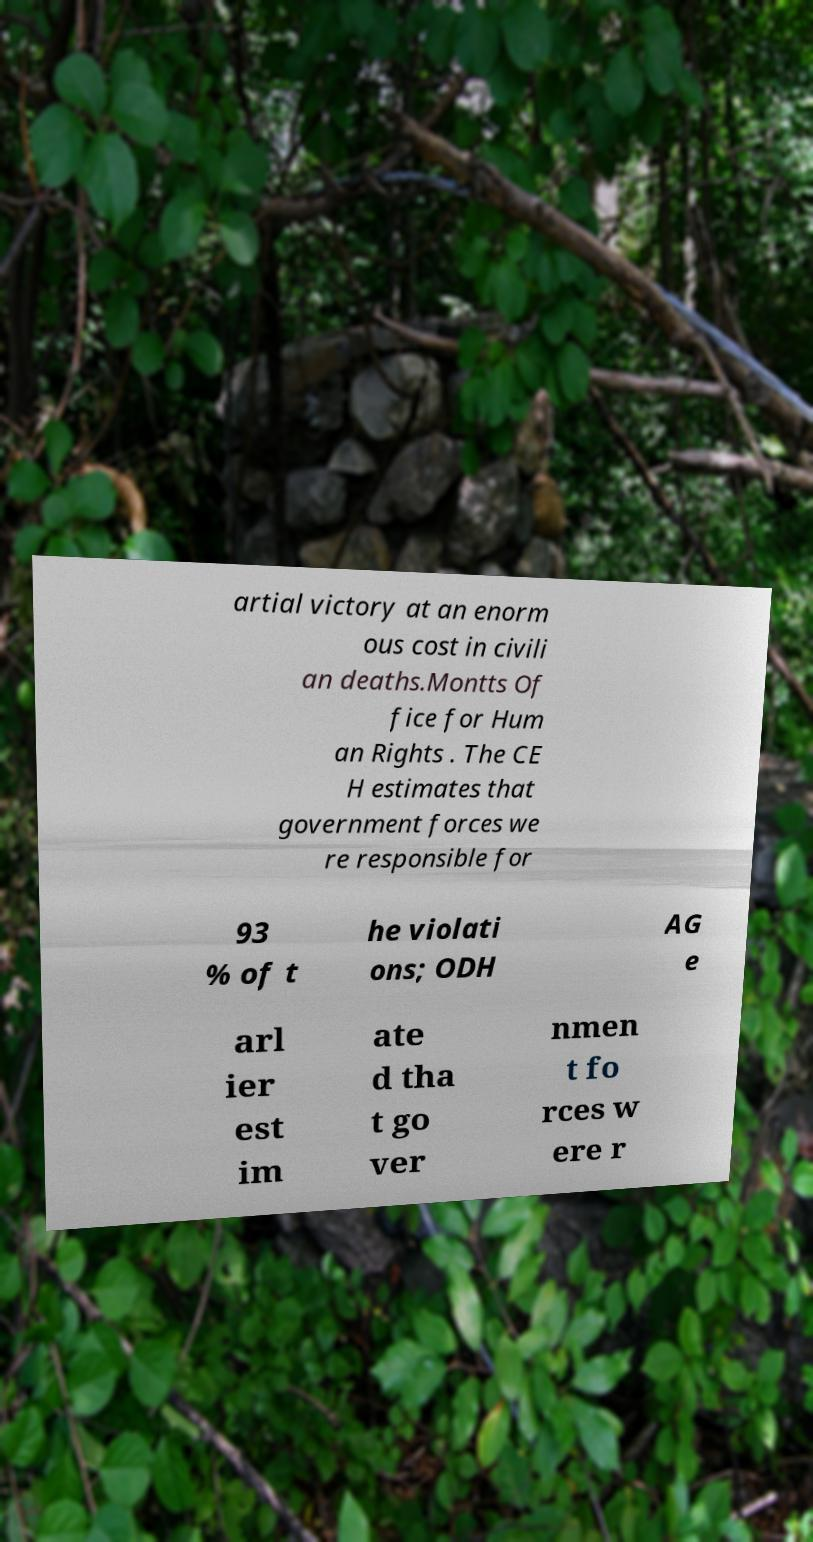Could you assist in decoding the text presented in this image and type it out clearly? artial victory at an enorm ous cost in civili an deaths.Montts Of fice for Hum an Rights . The CE H estimates that government forces we re responsible for 93 % of t he violati ons; ODH AG e arl ier est im ate d tha t go ver nmen t fo rces w ere r 